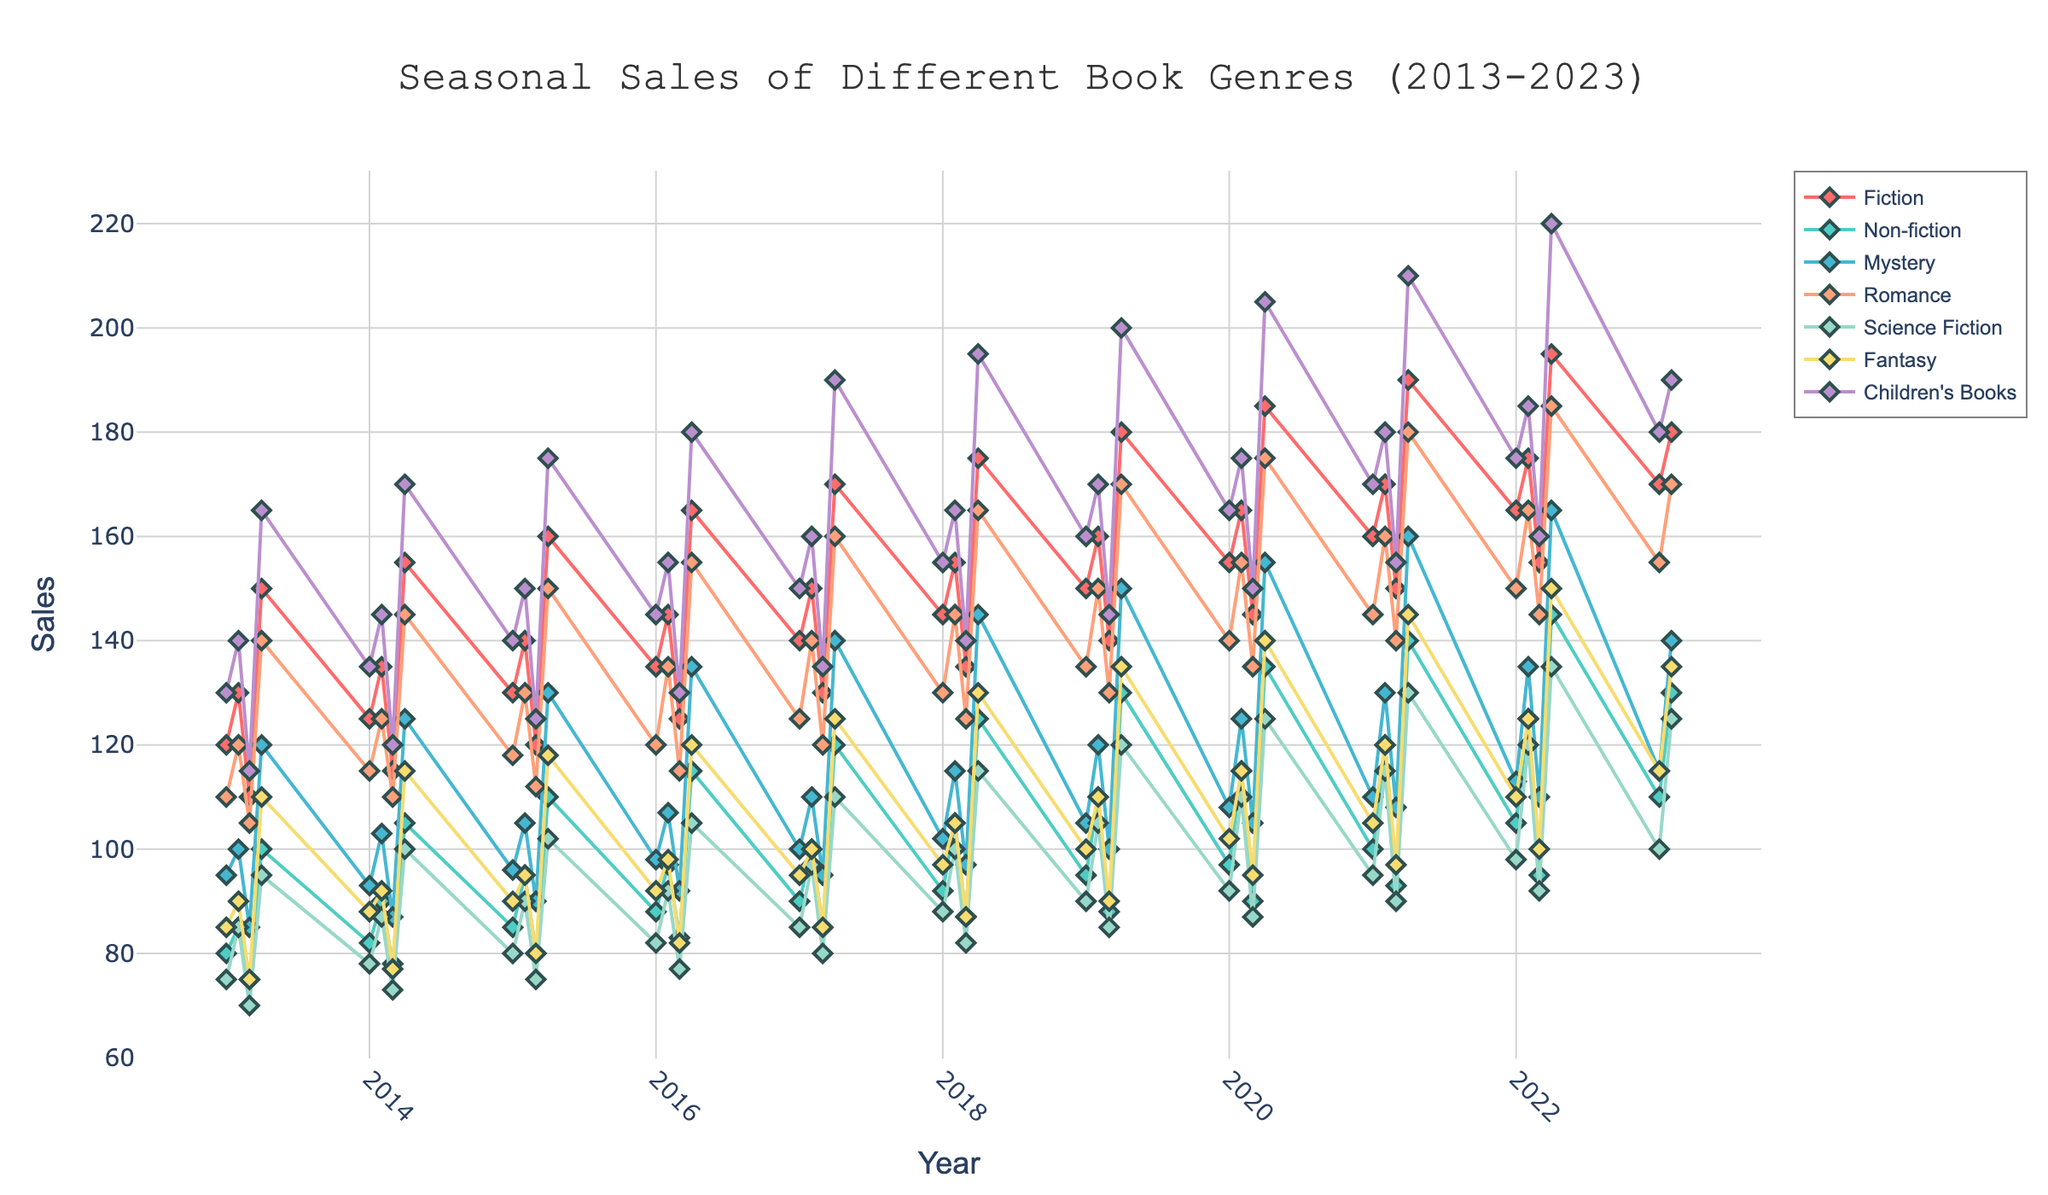What is the title of the figure? The title of the figure is mentioned at the top center of the plot. It reads "Seasonal Sales of Different Book Genres (2013-2023)".
Answer: Seasonal Sales of Different Book Genres (2013-2023) What genre has the highest sales in Q4 of 2022? To find the genre with the highest sales in Q4 of 2022, look for the point corresponding to Q4 2022 on the x-axis and then identify the genre with the highest value on the y-axis. "Children's Books" has the highest sales in Q4 2022.
Answer: Children's Books Which quarter shows the lowest sales for Mystery books over the decade? Observe the plot where the Mystery books are represented. Identify all the points and locate the one with the smallest y-axis value. The lowest sales for Mystery occurred in Q3 of 2013.
Answer: Q3 of 2013 What is the trend for Science Fiction sales over the decade? Examine the line corresponding to Science Fiction sales. Look at how it changes from the beginning to the end of the plot. It generally rises over the decade, showing an overall upward trend with some seasonal fluctuations.
Answer: Upward trend How do the sales of Non-fiction in Q1 2023 compare to Q1 2013? Find the points corresponding to Q1 of 2023 and Q1 of 2013 for Non-fiction. Compare the y-axis values at these points. The sales of Non-fiction in Q1 2023 are higher than in Q1 2013.
Answer: Higher By how much did Romance book sales increase from Q4 2013 to Q4 2022? Identify the sales values for Romance books in Q4 of 2013 and Q4 of 2022. Calculate the difference between the two values: 185 (Q4 2022) - 140 (Q4 2013) = 45.
Answer: 45 What are the seasonal patterns for Children's Books sales? Observe the cyclic nature of the sales line for Children's Books. Notice the upward peaks typically in Q4 each year and subsequent drops, indicating higher sales during the autumn/winter months and lower in other seasons.
Answer: Higher in Q4, lower in other seasons Which genre has the most consistent sales growth over the decade? Examine each genre's line and note the one with a steady upward movement without significant drops. Fantasy shows a consistent sales increase over the decade compared to other genres.
Answer: Fantasy What is the average sales value for Fiction books in Q4 over the entire decade? Collect all the Q4 Fiction sales points over the decade and calculate the average: (150 + 155 + 160 + 165 + 170 + 175 + 180 + 185 + 190 + 195) / 10 = 172.
Answer: 172 